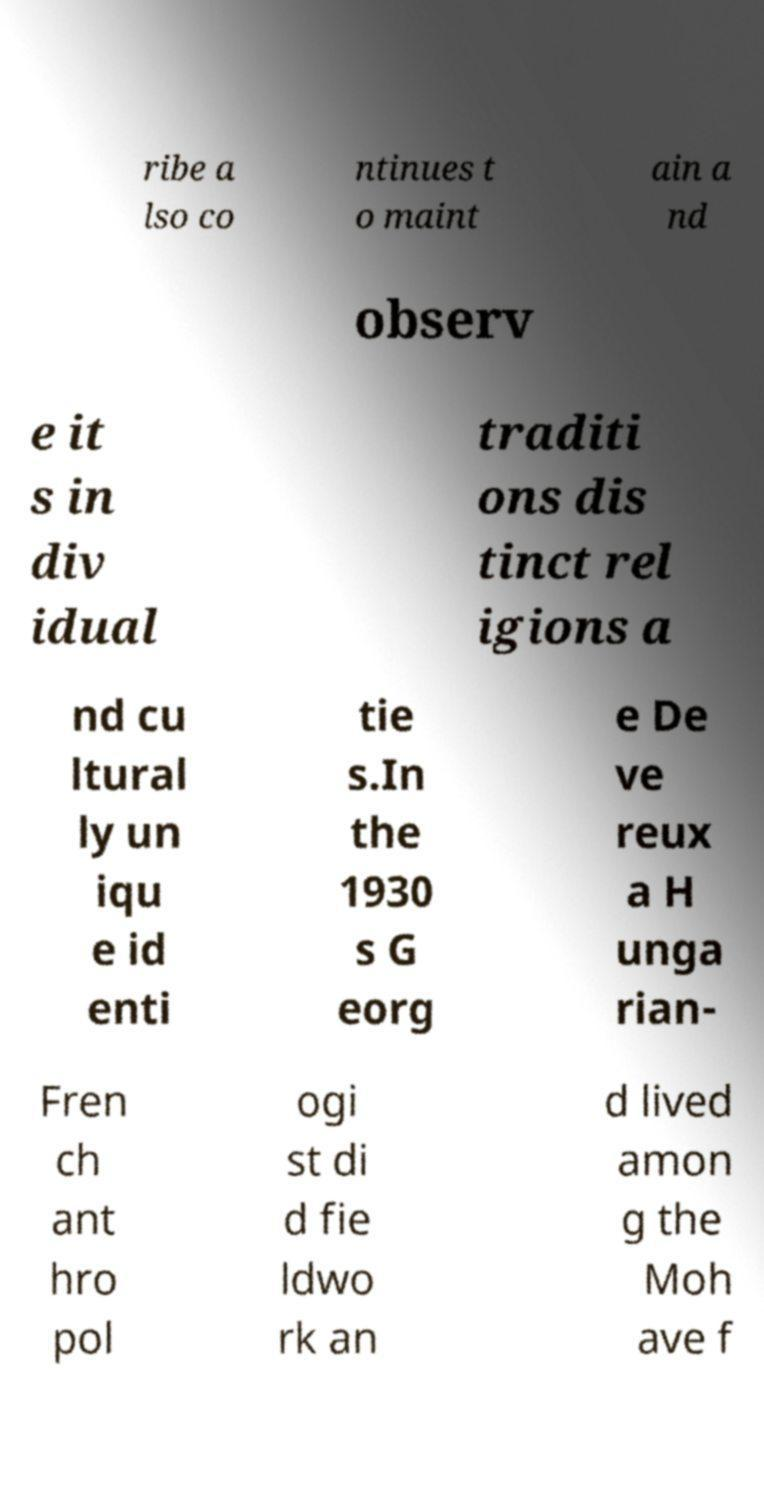Could you extract and type out the text from this image? ribe a lso co ntinues t o maint ain a nd observ e it s in div idual traditi ons dis tinct rel igions a nd cu ltural ly un iqu e id enti tie s.In the 1930 s G eorg e De ve reux a H unga rian- Fren ch ant hro pol ogi st di d fie ldwo rk an d lived amon g the Moh ave f 